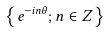Convert formula to latex. <formula><loc_0><loc_0><loc_500><loc_500>\left \{ e ^ { - i n \theta } ; n \in Z \right \}</formula> 